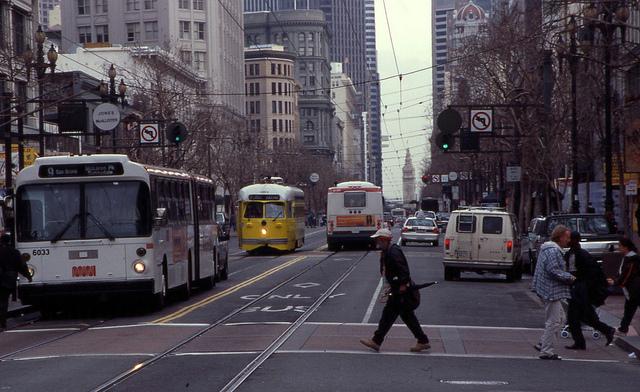How many buses are on the street?
Keep it brief. 3. Walk or don't walk?
Write a very short answer. Walk. What city is this bus in?
Be succinct. New york. Does the crosswalk sign say walk or don't walk?
Short answer required. Walk. How many cyclist are present?
Quick response, please. 0. How many people are crossing the road?
Be succinct. 4. Was this photo taken in the U.S.?
Keep it brief. Yes. What are the buses for?
Give a very brief answer. Transportation. What color is the light?
Quick response, please. Green. 